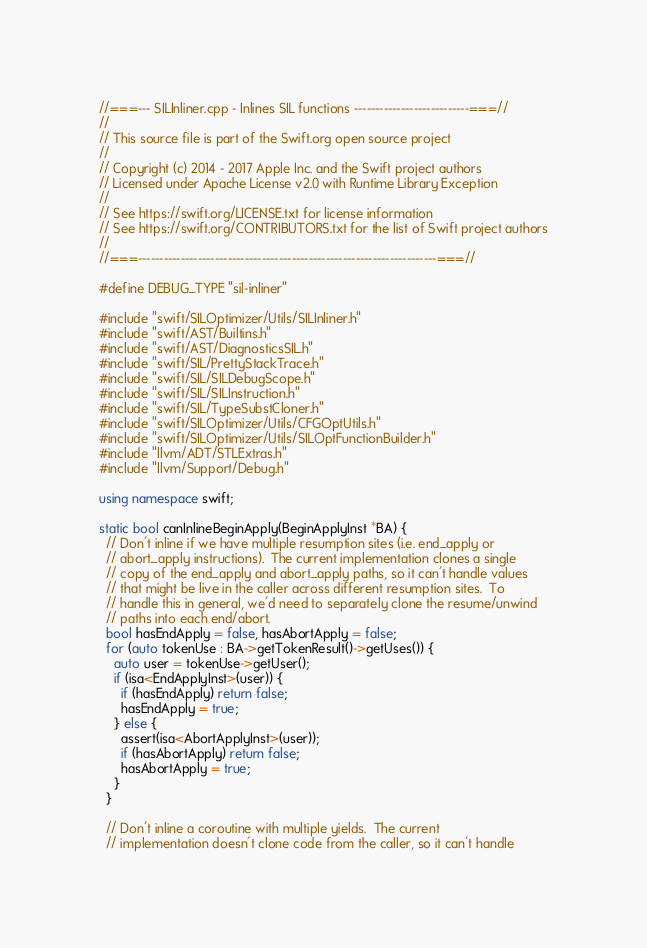Convert code to text. <code><loc_0><loc_0><loc_500><loc_500><_C++_>//===--- SILInliner.cpp - Inlines SIL functions ---------------------------===//
//
// This source file is part of the Swift.org open source project
//
// Copyright (c) 2014 - 2017 Apple Inc. and the Swift project authors
// Licensed under Apache License v2.0 with Runtime Library Exception
//
// See https://swift.org/LICENSE.txt for license information
// See https://swift.org/CONTRIBUTORS.txt for the list of Swift project authors
//
//===----------------------------------------------------------------------===//

#define DEBUG_TYPE "sil-inliner"

#include "swift/SILOptimizer/Utils/SILInliner.h"
#include "swift/AST/Builtins.h"
#include "swift/AST/DiagnosticsSIL.h"
#include "swift/SIL/PrettyStackTrace.h"
#include "swift/SIL/SILDebugScope.h"
#include "swift/SIL/SILInstruction.h"
#include "swift/SIL/TypeSubstCloner.h"
#include "swift/SILOptimizer/Utils/CFGOptUtils.h"
#include "swift/SILOptimizer/Utils/SILOptFunctionBuilder.h"
#include "llvm/ADT/STLExtras.h"
#include "llvm/Support/Debug.h"

using namespace swift;

static bool canInlineBeginApply(BeginApplyInst *BA) {
  // Don't inline if we have multiple resumption sites (i.e. end_apply or
  // abort_apply instructions).  The current implementation clones a single
  // copy of the end_apply and abort_apply paths, so it can't handle values
  // that might be live in the caller across different resumption sites.  To
  // handle this in general, we'd need to separately clone the resume/unwind
  // paths into each end/abort.
  bool hasEndApply = false, hasAbortApply = false;
  for (auto tokenUse : BA->getTokenResult()->getUses()) {
    auto user = tokenUse->getUser();
    if (isa<EndApplyInst>(user)) {
      if (hasEndApply) return false;
      hasEndApply = true;
    } else {
      assert(isa<AbortApplyInst>(user));
      if (hasAbortApply) return false;
      hasAbortApply = true;
    }
  }

  // Don't inline a coroutine with multiple yields.  The current
  // implementation doesn't clone code from the caller, so it can't handle</code> 